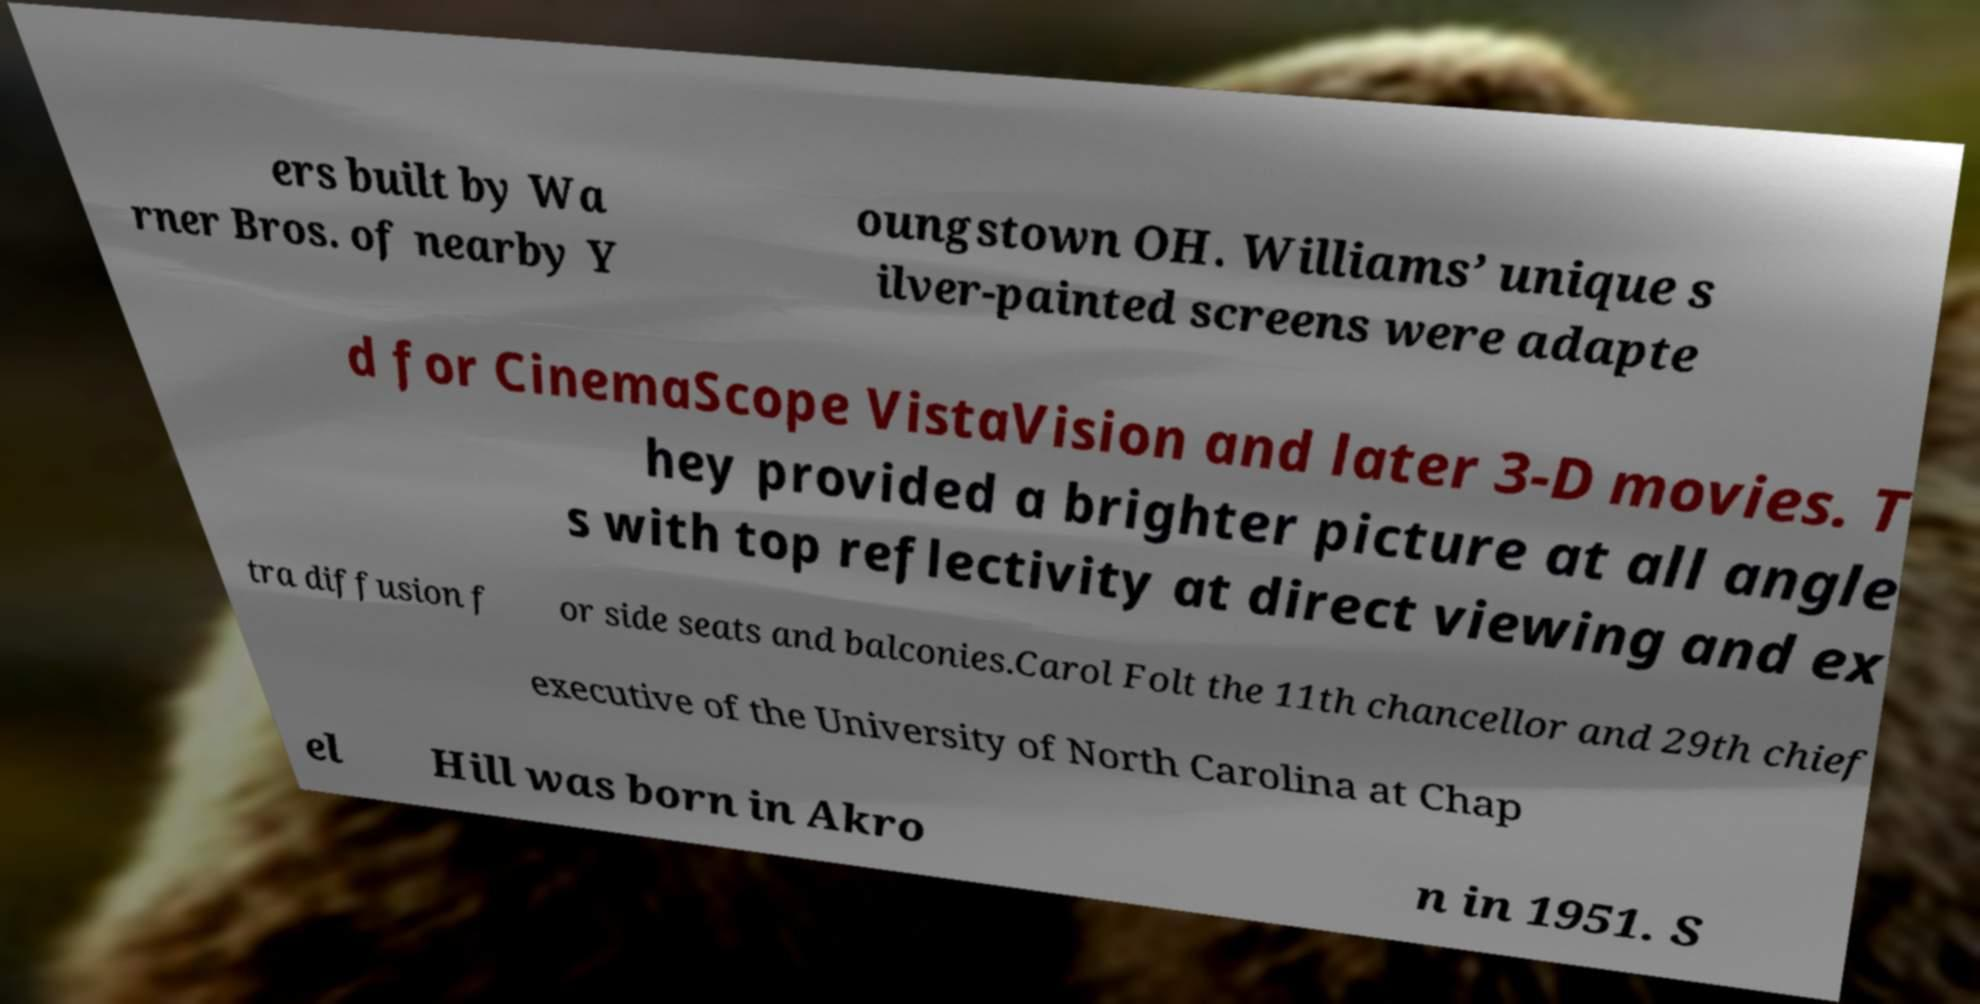Could you extract and type out the text from this image? ers built by Wa rner Bros. of nearby Y oungstown OH. Williams’ unique s ilver-painted screens were adapte d for CinemaScope VistaVision and later 3-D movies. T hey provided a brighter picture at all angle s with top reflectivity at direct viewing and ex tra diffusion f or side seats and balconies.Carol Folt the 11th chancellor and 29th chief executive of the University of North Carolina at Chap el Hill was born in Akro n in 1951. S 